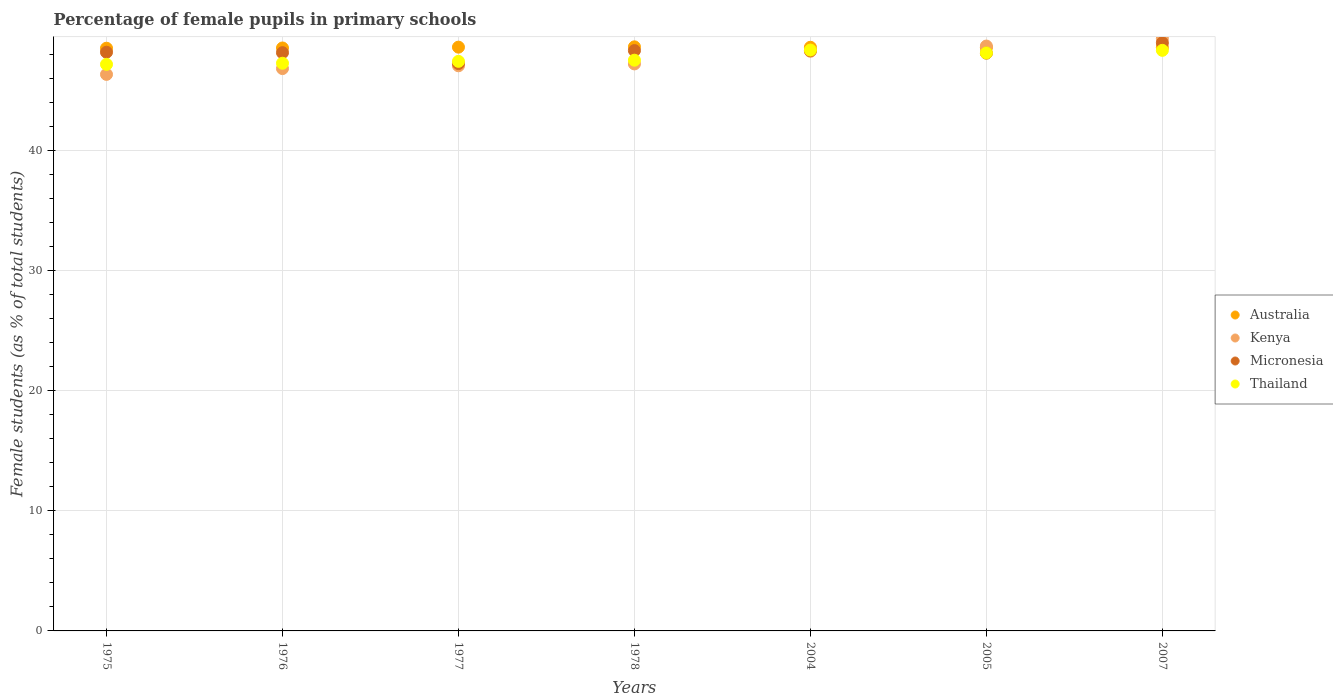How many different coloured dotlines are there?
Keep it short and to the point. 4. What is the percentage of female pupils in primary schools in Thailand in 2007?
Provide a short and direct response. 48.36. Across all years, what is the maximum percentage of female pupils in primary schools in Kenya?
Your answer should be compact. 49.36. Across all years, what is the minimum percentage of female pupils in primary schools in Micronesia?
Your answer should be very brief. 47.26. In which year was the percentage of female pupils in primary schools in Australia minimum?
Provide a short and direct response. 1975. What is the total percentage of female pupils in primary schools in Kenya in the graph?
Provide a short and direct response. 333.86. What is the difference between the percentage of female pupils in primary schools in Thailand in 1976 and that in 1978?
Make the answer very short. -0.25. What is the difference between the percentage of female pupils in primary schools in Kenya in 2004 and the percentage of female pupils in primary schools in Thailand in 1977?
Keep it short and to the point. 0.84. What is the average percentage of female pupils in primary schools in Kenya per year?
Offer a very short reply. 47.69. In the year 2007, what is the difference between the percentage of female pupils in primary schools in Micronesia and percentage of female pupils in primary schools in Kenya?
Make the answer very short. -0.37. In how many years, is the percentage of female pupils in primary schools in Thailand greater than 2 %?
Offer a very short reply. 7. What is the ratio of the percentage of female pupils in primary schools in Kenya in 1977 to that in 1978?
Offer a terse response. 1. Is the percentage of female pupils in primary schools in Thailand in 1976 less than that in 2007?
Provide a succinct answer. Yes. Is the difference between the percentage of female pupils in primary schools in Micronesia in 1975 and 2007 greater than the difference between the percentage of female pupils in primary schools in Kenya in 1975 and 2007?
Make the answer very short. Yes. What is the difference between the highest and the second highest percentage of female pupils in primary schools in Kenya?
Ensure brevity in your answer.  0.64. What is the difference between the highest and the lowest percentage of female pupils in primary schools in Thailand?
Provide a short and direct response. 1.19. In how many years, is the percentage of female pupils in primary schools in Kenya greater than the average percentage of female pupils in primary schools in Kenya taken over all years?
Your response must be concise. 3. Is it the case that in every year, the sum of the percentage of female pupils in primary schools in Kenya and percentage of female pupils in primary schools in Micronesia  is greater than the percentage of female pupils in primary schools in Australia?
Make the answer very short. Yes. Is the percentage of female pupils in primary schools in Kenya strictly less than the percentage of female pupils in primary schools in Australia over the years?
Make the answer very short. No. How many years are there in the graph?
Provide a short and direct response. 7. Are the values on the major ticks of Y-axis written in scientific E-notation?
Your answer should be compact. No. Does the graph contain any zero values?
Offer a terse response. No. Does the graph contain grids?
Your answer should be very brief. Yes. How many legend labels are there?
Give a very brief answer. 4. How are the legend labels stacked?
Your response must be concise. Vertical. What is the title of the graph?
Keep it short and to the point. Percentage of female pupils in primary schools. What is the label or title of the X-axis?
Offer a terse response. Years. What is the label or title of the Y-axis?
Your answer should be very brief. Female students (as % of total students). What is the Female students (as % of total students) of Australia in 1975?
Your response must be concise. 48.54. What is the Female students (as % of total students) of Kenya in 1975?
Ensure brevity in your answer.  46.36. What is the Female students (as % of total students) of Micronesia in 1975?
Offer a very short reply. 48.2. What is the Female students (as % of total students) in Thailand in 1975?
Offer a terse response. 47.2. What is the Female students (as % of total students) of Australia in 1976?
Your answer should be compact. 48.56. What is the Female students (as % of total students) in Kenya in 1976?
Ensure brevity in your answer.  46.84. What is the Female students (as % of total students) in Micronesia in 1976?
Ensure brevity in your answer.  48.17. What is the Female students (as % of total students) in Thailand in 1976?
Your answer should be very brief. 47.29. What is the Female students (as % of total students) of Australia in 1977?
Your answer should be very brief. 48.63. What is the Female students (as % of total students) in Kenya in 1977?
Provide a short and direct response. 47.08. What is the Female students (as % of total students) in Micronesia in 1977?
Your response must be concise. 47.26. What is the Female students (as % of total students) of Thailand in 1977?
Give a very brief answer. 47.45. What is the Female students (as % of total students) in Australia in 1978?
Give a very brief answer. 48.65. What is the Female students (as % of total students) in Kenya in 1978?
Your response must be concise. 47.23. What is the Female students (as % of total students) of Micronesia in 1978?
Offer a very short reply. 48.34. What is the Female students (as % of total students) of Thailand in 1978?
Offer a terse response. 47.54. What is the Female students (as % of total students) in Australia in 2004?
Keep it short and to the point. 48.62. What is the Female students (as % of total students) in Kenya in 2004?
Offer a terse response. 48.28. What is the Female students (as % of total students) in Micronesia in 2004?
Offer a terse response. 48.33. What is the Female students (as % of total students) of Thailand in 2004?
Give a very brief answer. 48.39. What is the Female students (as % of total students) of Australia in 2005?
Give a very brief answer. 48.59. What is the Female students (as % of total students) in Kenya in 2005?
Your response must be concise. 48.72. What is the Female students (as % of total students) in Micronesia in 2005?
Provide a short and direct response. 48.12. What is the Female students (as % of total students) in Thailand in 2005?
Make the answer very short. 48.14. What is the Female students (as % of total students) of Australia in 2007?
Your response must be concise. 48.6. What is the Female students (as % of total students) of Kenya in 2007?
Provide a succinct answer. 49.36. What is the Female students (as % of total students) in Micronesia in 2007?
Provide a succinct answer. 48.98. What is the Female students (as % of total students) in Thailand in 2007?
Keep it short and to the point. 48.36. Across all years, what is the maximum Female students (as % of total students) of Australia?
Provide a succinct answer. 48.65. Across all years, what is the maximum Female students (as % of total students) of Kenya?
Provide a short and direct response. 49.36. Across all years, what is the maximum Female students (as % of total students) of Micronesia?
Your answer should be very brief. 48.98. Across all years, what is the maximum Female students (as % of total students) of Thailand?
Your response must be concise. 48.39. Across all years, what is the minimum Female students (as % of total students) in Australia?
Provide a succinct answer. 48.54. Across all years, what is the minimum Female students (as % of total students) of Kenya?
Provide a succinct answer. 46.36. Across all years, what is the minimum Female students (as % of total students) of Micronesia?
Provide a short and direct response. 47.26. Across all years, what is the minimum Female students (as % of total students) of Thailand?
Provide a succinct answer. 47.2. What is the total Female students (as % of total students) of Australia in the graph?
Your answer should be very brief. 340.18. What is the total Female students (as % of total students) in Kenya in the graph?
Ensure brevity in your answer.  333.86. What is the total Female students (as % of total students) of Micronesia in the graph?
Ensure brevity in your answer.  337.41. What is the total Female students (as % of total students) in Thailand in the graph?
Offer a very short reply. 334.36. What is the difference between the Female students (as % of total students) of Australia in 1975 and that in 1976?
Offer a very short reply. -0.02. What is the difference between the Female students (as % of total students) in Kenya in 1975 and that in 1976?
Your response must be concise. -0.48. What is the difference between the Female students (as % of total students) of Micronesia in 1975 and that in 1976?
Your answer should be compact. 0.04. What is the difference between the Female students (as % of total students) in Thailand in 1975 and that in 1976?
Make the answer very short. -0.09. What is the difference between the Female students (as % of total students) in Australia in 1975 and that in 1977?
Provide a succinct answer. -0.09. What is the difference between the Female students (as % of total students) in Kenya in 1975 and that in 1977?
Provide a succinct answer. -0.72. What is the difference between the Female students (as % of total students) of Micronesia in 1975 and that in 1977?
Make the answer very short. 0.95. What is the difference between the Female students (as % of total students) in Thailand in 1975 and that in 1977?
Offer a very short reply. -0.25. What is the difference between the Female students (as % of total students) in Australia in 1975 and that in 1978?
Provide a succinct answer. -0.11. What is the difference between the Female students (as % of total students) of Kenya in 1975 and that in 1978?
Make the answer very short. -0.87. What is the difference between the Female students (as % of total students) in Micronesia in 1975 and that in 1978?
Provide a succinct answer. -0.14. What is the difference between the Female students (as % of total students) in Thailand in 1975 and that in 1978?
Give a very brief answer. -0.35. What is the difference between the Female students (as % of total students) of Australia in 1975 and that in 2004?
Keep it short and to the point. -0.08. What is the difference between the Female students (as % of total students) in Kenya in 1975 and that in 2004?
Provide a succinct answer. -1.93. What is the difference between the Female students (as % of total students) of Micronesia in 1975 and that in 2004?
Your answer should be very brief. -0.13. What is the difference between the Female students (as % of total students) of Thailand in 1975 and that in 2004?
Make the answer very short. -1.19. What is the difference between the Female students (as % of total students) in Australia in 1975 and that in 2005?
Make the answer very short. -0.05. What is the difference between the Female students (as % of total students) of Kenya in 1975 and that in 2005?
Provide a succinct answer. -2.36. What is the difference between the Female students (as % of total students) in Micronesia in 1975 and that in 2005?
Ensure brevity in your answer.  0.08. What is the difference between the Female students (as % of total students) in Thailand in 1975 and that in 2005?
Your answer should be compact. -0.95. What is the difference between the Female students (as % of total students) of Australia in 1975 and that in 2007?
Offer a terse response. -0.06. What is the difference between the Female students (as % of total students) in Kenya in 1975 and that in 2007?
Your answer should be compact. -3. What is the difference between the Female students (as % of total students) in Micronesia in 1975 and that in 2007?
Offer a very short reply. -0.78. What is the difference between the Female students (as % of total students) in Thailand in 1975 and that in 2007?
Your answer should be very brief. -1.17. What is the difference between the Female students (as % of total students) in Australia in 1976 and that in 1977?
Your response must be concise. -0.07. What is the difference between the Female students (as % of total students) in Kenya in 1976 and that in 1977?
Offer a very short reply. -0.23. What is the difference between the Female students (as % of total students) of Micronesia in 1976 and that in 1977?
Keep it short and to the point. 0.91. What is the difference between the Female students (as % of total students) in Thailand in 1976 and that in 1977?
Provide a short and direct response. -0.16. What is the difference between the Female students (as % of total students) in Australia in 1976 and that in 1978?
Ensure brevity in your answer.  -0.09. What is the difference between the Female students (as % of total students) in Kenya in 1976 and that in 1978?
Your answer should be compact. -0.39. What is the difference between the Female students (as % of total students) in Micronesia in 1976 and that in 1978?
Offer a very short reply. -0.17. What is the difference between the Female students (as % of total students) of Thailand in 1976 and that in 1978?
Your answer should be very brief. -0.25. What is the difference between the Female students (as % of total students) in Australia in 1976 and that in 2004?
Ensure brevity in your answer.  -0.06. What is the difference between the Female students (as % of total students) of Kenya in 1976 and that in 2004?
Ensure brevity in your answer.  -1.44. What is the difference between the Female students (as % of total students) of Micronesia in 1976 and that in 2004?
Your response must be concise. -0.17. What is the difference between the Female students (as % of total students) in Thailand in 1976 and that in 2004?
Provide a succinct answer. -1.1. What is the difference between the Female students (as % of total students) in Australia in 1976 and that in 2005?
Keep it short and to the point. -0.03. What is the difference between the Female students (as % of total students) in Kenya in 1976 and that in 2005?
Offer a terse response. -1.88. What is the difference between the Female students (as % of total students) of Micronesia in 1976 and that in 2005?
Provide a succinct answer. 0.04. What is the difference between the Female students (as % of total students) of Thailand in 1976 and that in 2005?
Offer a terse response. -0.86. What is the difference between the Female students (as % of total students) in Australia in 1976 and that in 2007?
Your response must be concise. -0.04. What is the difference between the Female students (as % of total students) in Kenya in 1976 and that in 2007?
Offer a terse response. -2.52. What is the difference between the Female students (as % of total students) in Micronesia in 1976 and that in 2007?
Keep it short and to the point. -0.82. What is the difference between the Female students (as % of total students) of Thailand in 1976 and that in 2007?
Your answer should be very brief. -1.07. What is the difference between the Female students (as % of total students) in Australia in 1977 and that in 1978?
Your response must be concise. -0.03. What is the difference between the Female students (as % of total students) of Kenya in 1977 and that in 1978?
Your answer should be compact. -0.15. What is the difference between the Female students (as % of total students) in Micronesia in 1977 and that in 1978?
Provide a short and direct response. -1.08. What is the difference between the Female students (as % of total students) in Thailand in 1977 and that in 1978?
Make the answer very short. -0.1. What is the difference between the Female students (as % of total students) in Australia in 1977 and that in 2004?
Offer a very short reply. 0.01. What is the difference between the Female students (as % of total students) in Kenya in 1977 and that in 2004?
Your answer should be very brief. -1.21. What is the difference between the Female students (as % of total students) in Micronesia in 1977 and that in 2004?
Your answer should be compact. -1.08. What is the difference between the Female students (as % of total students) of Thailand in 1977 and that in 2004?
Provide a short and direct response. -0.94. What is the difference between the Female students (as % of total students) in Australia in 1977 and that in 2005?
Offer a terse response. 0.04. What is the difference between the Female students (as % of total students) of Kenya in 1977 and that in 2005?
Your answer should be compact. -1.64. What is the difference between the Female students (as % of total students) in Micronesia in 1977 and that in 2005?
Keep it short and to the point. -0.87. What is the difference between the Female students (as % of total students) of Thailand in 1977 and that in 2005?
Your response must be concise. -0.7. What is the difference between the Female students (as % of total students) in Australia in 1977 and that in 2007?
Offer a very short reply. 0.03. What is the difference between the Female students (as % of total students) in Kenya in 1977 and that in 2007?
Keep it short and to the point. -2.28. What is the difference between the Female students (as % of total students) in Micronesia in 1977 and that in 2007?
Offer a very short reply. -1.73. What is the difference between the Female students (as % of total students) in Thailand in 1977 and that in 2007?
Your response must be concise. -0.92. What is the difference between the Female students (as % of total students) of Australia in 1978 and that in 2004?
Offer a terse response. 0.04. What is the difference between the Female students (as % of total students) in Kenya in 1978 and that in 2004?
Give a very brief answer. -1.05. What is the difference between the Female students (as % of total students) in Micronesia in 1978 and that in 2004?
Give a very brief answer. 0.01. What is the difference between the Female students (as % of total students) in Thailand in 1978 and that in 2004?
Give a very brief answer. -0.84. What is the difference between the Female students (as % of total students) of Australia in 1978 and that in 2005?
Make the answer very short. 0.06. What is the difference between the Female students (as % of total students) of Kenya in 1978 and that in 2005?
Provide a succinct answer. -1.49. What is the difference between the Female students (as % of total students) of Micronesia in 1978 and that in 2005?
Keep it short and to the point. 0.22. What is the difference between the Female students (as % of total students) in Thailand in 1978 and that in 2005?
Provide a succinct answer. -0.6. What is the difference between the Female students (as % of total students) in Australia in 1978 and that in 2007?
Provide a succinct answer. 0.05. What is the difference between the Female students (as % of total students) in Kenya in 1978 and that in 2007?
Offer a terse response. -2.13. What is the difference between the Female students (as % of total students) in Micronesia in 1978 and that in 2007?
Provide a succinct answer. -0.64. What is the difference between the Female students (as % of total students) in Thailand in 1978 and that in 2007?
Your answer should be compact. -0.82. What is the difference between the Female students (as % of total students) of Australia in 2004 and that in 2005?
Give a very brief answer. 0.02. What is the difference between the Female students (as % of total students) of Kenya in 2004 and that in 2005?
Provide a short and direct response. -0.43. What is the difference between the Female students (as % of total students) in Micronesia in 2004 and that in 2005?
Ensure brevity in your answer.  0.21. What is the difference between the Female students (as % of total students) in Thailand in 2004 and that in 2005?
Your answer should be very brief. 0.24. What is the difference between the Female students (as % of total students) in Australia in 2004 and that in 2007?
Provide a succinct answer. 0.02. What is the difference between the Female students (as % of total students) of Kenya in 2004 and that in 2007?
Ensure brevity in your answer.  -1.07. What is the difference between the Female students (as % of total students) of Micronesia in 2004 and that in 2007?
Provide a succinct answer. -0.65. What is the difference between the Female students (as % of total students) in Thailand in 2004 and that in 2007?
Your answer should be very brief. 0.03. What is the difference between the Female students (as % of total students) in Australia in 2005 and that in 2007?
Offer a very short reply. -0.01. What is the difference between the Female students (as % of total students) of Kenya in 2005 and that in 2007?
Ensure brevity in your answer.  -0.64. What is the difference between the Female students (as % of total students) of Micronesia in 2005 and that in 2007?
Give a very brief answer. -0.86. What is the difference between the Female students (as % of total students) in Thailand in 2005 and that in 2007?
Offer a very short reply. -0.22. What is the difference between the Female students (as % of total students) of Australia in 1975 and the Female students (as % of total students) of Kenya in 1976?
Give a very brief answer. 1.7. What is the difference between the Female students (as % of total students) of Australia in 1975 and the Female students (as % of total students) of Micronesia in 1976?
Make the answer very short. 0.37. What is the difference between the Female students (as % of total students) in Australia in 1975 and the Female students (as % of total students) in Thailand in 1976?
Offer a very short reply. 1.25. What is the difference between the Female students (as % of total students) of Kenya in 1975 and the Female students (as % of total students) of Micronesia in 1976?
Offer a very short reply. -1.81. What is the difference between the Female students (as % of total students) in Kenya in 1975 and the Female students (as % of total students) in Thailand in 1976?
Your answer should be very brief. -0.93. What is the difference between the Female students (as % of total students) of Micronesia in 1975 and the Female students (as % of total students) of Thailand in 1976?
Provide a succinct answer. 0.92. What is the difference between the Female students (as % of total students) in Australia in 1975 and the Female students (as % of total students) in Kenya in 1977?
Offer a very short reply. 1.46. What is the difference between the Female students (as % of total students) of Australia in 1975 and the Female students (as % of total students) of Micronesia in 1977?
Offer a terse response. 1.28. What is the difference between the Female students (as % of total students) of Australia in 1975 and the Female students (as % of total students) of Thailand in 1977?
Provide a short and direct response. 1.09. What is the difference between the Female students (as % of total students) in Kenya in 1975 and the Female students (as % of total students) in Micronesia in 1977?
Offer a terse response. -0.9. What is the difference between the Female students (as % of total students) in Kenya in 1975 and the Female students (as % of total students) in Thailand in 1977?
Offer a very short reply. -1.09. What is the difference between the Female students (as % of total students) in Micronesia in 1975 and the Female students (as % of total students) in Thailand in 1977?
Offer a very short reply. 0.76. What is the difference between the Female students (as % of total students) of Australia in 1975 and the Female students (as % of total students) of Kenya in 1978?
Your answer should be compact. 1.31. What is the difference between the Female students (as % of total students) in Australia in 1975 and the Female students (as % of total students) in Micronesia in 1978?
Provide a short and direct response. 0.2. What is the difference between the Female students (as % of total students) in Australia in 1975 and the Female students (as % of total students) in Thailand in 1978?
Offer a very short reply. 1. What is the difference between the Female students (as % of total students) of Kenya in 1975 and the Female students (as % of total students) of Micronesia in 1978?
Offer a terse response. -1.98. What is the difference between the Female students (as % of total students) of Kenya in 1975 and the Female students (as % of total students) of Thailand in 1978?
Provide a succinct answer. -1.18. What is the difference between the Female students (as % of total students) of Micronesia in 1975 and the Female students (as % of total students) of Thailand in 1978?
Give a very brief answer. 0.66. What is the difference between the Female students (as % of total students) in Australia in 1975 and the Female students (as % of total students) in Kenya in 2004?
Offer a very short reply. 0.25. What is the difference between the Female students (as % of total students) of Australia in 1975 and the Female students (as % of total students) of Micronesia in 2004?
Ensure brevity in your answer.  0.2. What is the difference between the Female students (as % of total students) of Australia in 1975 and the Female students (as % of total students) of Thailand in 2004?
Your answer should be very brief. 0.15. What is the difference between the Female students (as % of total students) in Kenya in 1975 and the Female students (as % of total students) in Micronesia in 2004?
Your answer should be very brief. -1.97. What is the difference between the Female students (as % of total students) in Kenya in 1975 and the Female students (as % of total students) in Thailand in 2004?
Offer a very short reply. -2.03. What is the difference between the Female students (as % of total students) in Micronesia in 1975 and the Female students (as % of total students) in Thailand in 2004?
Give a very brief answer. -0.18. What is the difference between the Female students (as % of total students) in Australia in 1975 and the Female students (as % of total students) in Kenya in 2005?
Your response must be concise. -0.18. What is the difference between the Female students (as % of total students) in Australia in 1975 and the Female students (as % of total students) in Micronesia in 2005?
Make the answer very short. 0.41. What is the difference between the Female students (as % of total students) in Australia in 1975 and the Female students (as % of total students) in Thailand in 2005?
Offer a terse response. 0.39. What is the difference between the Female students (as % of total students) in Kenya in 1975 and the Female students (as % of total students) in Micronesia in 2005?
Provide a succinct answer. -1.77. What is the difference between the Female students (as % of total students) of Kenya in 1975 and the Female students (as % of total students) of Thailand in 2005?
Give a very brief answer. -1.79. What is the difference between the Female students (as % of total students) in Micronesia in 1975 and the Female students (as % of total students) in Thailand in 2005?
Your answer should be compact. 0.06. What is the difference between the Female students (as % of total students) of Australia in 1975 and the Female students (as % of total students) of Kenya in 2007?
Ensure brevity in your answer.  -0.82. What is the difference between the Female students (as % of total students) in Australia in 1975 and the Female students (as % of total students) in Micronesia in 2007?
Keep it short and to the point. -0.45. What is the difference between the Female students (as % of total students) in Australia in 1975 and the Female students (as % of total students) in Thailand in 2007?
Provide a short and direct response. 0.18. What is the difference between the Female students (as % of total students) of Kenya in 1975 and the Female students (as % of total students) of Micronesia in 2007?
Make the answer very short. -2.63. What is the difference between the Female students (as % of total students) of Kenya in 1975 and the Female students (as % of total students) of Thailand in 2007?
Provide a succinct answer. -2. What is the difference between the Female students (as % of total students) in Micronesia in 1975 and the Female students (as % of total students) in Thailand in 2007?
Your response must be concise. -0.16. What is the difference between the Female students (as % of total students) of Australia in 1976 and the Female students (as % of total students) of Kenya in 1977?
Your answer should be compact. 1.48. What is the difference between the Female students (as % of total students) in Australia in 1976 and the Female students (as % of total students) in Micronesia in 1977?
Ensure brevity in your answer.  1.3. What is the difference between the Female students (as % of total students) in Australia in 1976 and the Female students (as % of total students) in Thailand in 1977?
Offer a very short reply. 1.11. What is the difference between the Female students (as % of total students) in Kenya in 1976 and the Female students (as % of total students) in Micronesia in 1977?
Provide a short and direct response. -0.42. What is the difference between the Female students (as % of total students) of Kenya in 1976 and the Female students (as % of total students) of Thailand in 1977?
Ensure brevity in your answer.  -0.6. What is the difference between the Female students (as % of total students) in Micronesia in 1976 and the Female students (as % of total students) in Thailand in 1977?
Provide a short and direct response. 0.72. What is the difference between the Female students (as % of total students) of Australia in 1976 and the Female students (as % of total students) of Kenya in 1978?
Ensure brevity in your answer.  1.33. What is the difference between the Female students (as % of total students) of Australia in 1976 and the Female students (as % of total students) of Micronesia in 1978?
Your answer should be compact. 0.22. What is the difference between the Female students (as % of total students) in Australia in 1976 and the Female students (as % of total students) in Thailand in 1978?
Your response must be concise. 1.02. What is the difference between the Female students (as % of total students) of Kenya in 1976 and the Female students (as % of total students) of Micronesia in 1978?
Offer a very short reply. -1.5. What is the difference between the Female students (as % of total students) of Kenya in 1976 and the Female students (as % of total students) of Thailand in 1978?
Offer a very short reply. -0.7. What is the difference between the Female students (as % of total students) in Micronesia in 1976 and the Female students (as % of total students) in Thailand in 1978?
Make the answer very short. 0.63. What is the difference between the Female students (as % of total students) of Australia in 1976 and the Female students (as % of total students) of Kenya in 2004?
Provide a short and direct response. 0.27. What is the difference between the Female students (as % of total students) of Australia in 1976 and the Female students (as % of total students) of Micronesia in 2004?
Provide a succinct answer. 0.23. What is the difference between the Female students (as % of total students) in Australia in 1976 and the Female students (as % of total students) in Thailand in 2004?
Make the answer very short. 0.17. What is the difference between the Female students (as % of total students) in Kenya in 1976 and the Female students (as % of total students) in Micronesia in 2004?
Ensure brevity in your answer.  -1.49. What is the difference between the Female students (as % of total students) in Kenya in 1976 and the Female students (as % of total students) in Thailand in 2004?
Offer a terse response. -1.54. What is the difference between the Female students (as % of total students) in Micronesia in 1976 and the Female students (as % of total students) in Thailand in 2004?
Your answer should be very brief. -0.22. What is the difference between the Female students (as % of total students) in Australia in 1976 and the Female students (as % of total students) in Kenya in 2005?
Ensure brevity in your answer.  -0.16. What is the difference between the Female students (as % of total students) of Australia in 1976 and the Female students (as % of total students) of Micronesia in 2005?
Ensure brevity in your answer.  0.43. What is the difference between the Female students (as % of total students) in Australia in 1976 and the Female students (as % of total students) in Thailand in 2005?
Offer a terse response. 0.41. What is the difference between the Female students (as % of total students) in Kenya in 1976 and the Female students (as % of total students) in Micronesia in 2005?
Your response must be concise. -1.28. What is the difference between the Female students (as % of total students) in Kenya in 1976 and the Female students (as % of total students) in Thailand in 2005?
Give a very brief answer. -1.3. What is the difference between the Female students (as % of total students) of Micronesia in 1976 and the Female students (as % of total students) of Thailand in 2005?
Provide a short and direct response. 0.02. What is the difference between the Female students (as % of total students) in Australia in 1976 and the Female students (as % of total students) in Kenya in 2007?
Provide a short and direct response. -0.8. What is the difference between the Female students (as % of total students) in Australia in 1976 and the Female students (as % of total students) in Micronesia in 2007?
Provide a succinct answer. -0.43. What is the difference between the Female students (as % of total students) in Australia in 1976 and the Female students (as % of total students) in Thailand in 2007?
Ensure brevity in your answer.  0.2. What is the difference between the Female students (as % of total students) in Kenya in 1976 and the Female students (as % of total students) in Micronesia in 2007?
Your response must be concise. -2.14. What is the difference between the Female students (as % of total students) in Kenya in 1976 and the Female students (as % of total students) in Thailand in 2007?
Provide a succinct answer. -1.52. What is the difference between the Female students (as % of total students) in Micronesia in 1976 and the Female students (as % of total students) in Thailand in 2007?
Your response must be concise. -0.19. What is the difference between the Female students (as % of total students) of Australia in 1977 and the Female students (as % of total students) of Kenya in 1978?
Your answer should be compact. 1.4. What is the difference between the Female students (as % of total students) of Australia in 1977 and the Female students (as % of total students) of Micronesia in 1978?
Your answer should be compact. 0.29. What is the difference between the Female students (as % of total students) of Australia in 1977 and the Female students (as % of total students) of Thailand in 1978?
Give a very brief answer. 1.09. What is the difference between the Female students (as % of total students) in Kenya in 1977 and the Female students (as % of total students) in Micronesia in 1978?
Make the answer very short. -1.27. What is the difference between the Female students (as % of total students) in Kenya in 1977 and the Female students (as % of total students) in Thailand in 1978?
Make the answer very short. -0.47. What is the difference between the Female students (as % of total students) in Micronesia in 1977 and the Female students (as % of total students) in Thailand in 1978?
Ensure brevity in your answer.  -0.28. What is the difference between the Female students (as % of total students) of Australia in 1977 and the Female students (as % of total students) of Kenya in 2004?
Your answer should be very brief. 0.34. What is the difference between the Female students (as % of total students) in Australia in 1977 and the Female students (as % of total students) in Micronesia in 2004?
Your answer should be compact. 0.29. What is the difference between the Female students (as % of total students) in Australia in 1977 and the Female students (as % of total students) in Thailand in 2004?
Offer a very short reply. 0.24. What is the difference between the Female students (as % of total students) in Kenya in 1977 and the Female students (as % of total students) in Micronesia in 2004?
Provide a succinct answer. -1.26. What is the difference between the Female students (as % of total students) in Kenya in 1977 and the Female students (as % of total students) in Thailand in 2004?
Provide a short and direct response. -1.31. What is the difference between the Female students (as % of total students) of Micronesia in 1977 and the Female students (as % of total students) of Thailand in 2004?
Your answer should be very brief. -1.13. What is the difference between the Female students (as % of total students) in Australia in 1977 and the Female students (as % of total students) in Kenya in 2005?
Your response must be concise. -0.09. What is the difference between the Female students (as % of total students) in Australia in 1977 and the Female students (as % of total students) in Micronesia in 2005?
Offer a very short reply. 0.5. What is the difference between the Female students (as % of total students) in Australia in 1977 and the Female students (as % of total students) in Thailand in 2005?
Give a very brief answer. 0.48. What is the difference between the Female students (as % of total students) in Kenya in 1977 and the Female students (as % of total students) in Micronesia in 2005?
Make the answer very short. -1.05. What is the difference between the Female students (as % of total students) of Kenya in 1977 and the Female students (as % of total students) of Thailand in 2005?
Offer a very short reply. -1.07. What is the difference between the Female students (as % of total students) of Micronesia in 1977 and the Female students (as % of total students) of Thailand in 2005?
Make the answer very short. -0.89. What is the difference between the Female students (as % of total students) of Australia in 1977 and the Female students (as % of total students) of Kenya in 2007?
Your answer should be very brief. -0.73. What is the difference between the Female students (as % of total students) of Australia in 1977 and the Female students (as % of total students) of Micronesia in 2007?
Offer a very short reply. -0.36. What is the difference between the Female students (as % of total students) in Australia in 1977 and the Female students (as % of total students) in Thailand in 2007?
Keep it short and to the point. 0.27. What is the difference between the Female students (as % of total students) in Kenya in 1977 and the Female students (as % of total students) in Micronesia in 2007?
Your answer should be compact. -1.91. What is the difference between the Female students (as % of total students) of Kenya in 1977 and the Female students (as % of total students) of Thailand in 2007?
Provide a short and direct response. -1.29. What is the difference between the Female students (as % of total students) in Micronesia in 1977 and the Female students (as % of total students) in Thailand in 2007?
Provide a succinct answer. -1.1. What is the difference between the Female students (as % of total students) in Australia in 1978 and the Female students (as % of total students) in Kenya in 2004?
Make the answer very short. 0.37. What is the difference between the Female students (as % of total students) in Australia in 1978 and the Female students (as % of total students) in Micronesia in 2004?
Provide a short and direct response. 0.32. What is the difference between the Female students (as % of total students) in Australia in 1978 and the Female students (as % of total students) in Thailand in 2004?
Your response must be concise. 0.27. What is the difference between the Female students (as % of total students) of Kenya in 1978 and the Female students (as % of total students) of Micronesia in 2004?
Offer a very short reply. -1.1. What is the difference between the Female students (as % of total students) in Kenya in 1978 and the Female students (as % of total students) in Thailand in 2004?
Make the answer very short. -1.16. What is the difference between the Female students (as % of total students) of Micronesia in 1978 and the Female students (as % of total students) of Thailand in 2004?
Provide a short and direct response. -0.04. What is the difference between the Female students (as % of total students) in Australia in 1978 and the Female students (as % of total students) in Kenya in 2005?
Keep it short and to the point. -0.07. What is the difference between the Female students (as % of total students) in Australia in 1978 and the Female students (as % of total students) in Micronesia in 2005?
Offer a very short reply. 0.53. What is the difference between the Female students (as % of total students) in Australia in 1978 and the Female students (as % of total students) in Thailand in 2005?
Give a very brief answer. 0.51. What is the difference between the Female students (as % of total students) of Kenya in 1978 and the Female students (as % of total students) of Micronesia in 2005?
Your response must be concise. -0.89. What is the difference between the Female students (as % of total students) of Kenya in 1978 and the Female students (as % of total students) of Thailand in 2005?
Provide a short and direct response. -0.91. What is the difference between the Female students (as % of total students) of Micronesia in 1978 and the Female students (as % of total students) of Thailand in 2005?
Keep it short and to the point. 0.2. What is the difference between the Female students (as % of total students) in Australia in 1978 and the Female students (as % of total students) in Kenya in 2007?
Offer a very short reply. -0.71. What is the difference between the Female students (as % of total students) of Australia in 1978 and the Female students (as % of total students) of Micronesia in 2007?
Your answer should be very brief. -0.33. What is the difference between the Female students (as % of total students) in Australia in 1978 and the Female students (as % of total students) in Thailand in 2007?
Keep it short and to the point. 0.29. What is the difference between the Female students (as % of total students) in Kenya in 1978 and the Female students (as % of total students) in Micronesia in 2007?
Your answer should be very brief. -1.75. What is the difference between the Female students (as % of total students) of Kenya in 1978 and the Female students (as % of total students) of Thailand in 2007?
Ensure brevity in your answer.  -1.13. What is the difference between the Female students (as % of total students) of Micronesia in 1978 and the Female students (as % of total students) of Thailand in 2007?
Offer a very short reply. -0.02. What is the difference between the Female students (as % of total students) in Australia in 2004 and the Female students (as % of total students) in Kenya in 2005?
Your answer should be compact. -0.1. What is the difference between the Female students (as % of total students) of Australia in 2004 and the Female students (as % of total students) of Micronesia in 2005?
Keep it short and to the point. 0.49. What is the difference between the Female students (as % of total students) in Australia in 2004 and the Female students (as % of total students) in Thailand in 2005?
Offer a terse response. 0.47. What is the difference between the Female students (as % of total students) in Kenya in 2004 and the Female students (as % of total students) in Micronesia in 2005?
Your answer should be very brief. 0.16. What is the difference between the Female students (as % of total students) of Kenya in 2004 and the Female students (as % of total students) of Thailand in 2005?
Offer a terse response. 0.14. What is the difference between the Female students (as % of total students) of Micronesia in 2004 and the Female students (as % of total students) of Thailand in 2005?
Your answer should be very brief. 0.19. What is the difference between the Female students (as % of total students) in Australia in 2004 and the Female students (as % of total students) in Kenya in 2007?
Offer a terse response. -0.74. What is the difference between the Female students (as % of total students) of Australia in 2004 and the Female students (as % of total students) of Micronesia in 2007?
Your response must be concise. -0.37. What is the difference between the Female students (as % of total students) of Australia in 2004 and the Female students (as % of total students) of Thailand in 2007?
Provide a short and direct response. 0.26. What is the difference between the Female students (as % of total students) of Kenya in 2004 and the Female students (as % of total students) of Micronesia in 2007?
Ensure brevity in your answer.  -0.7. What is the difference between the Female students (as % of total students) in Kenya in 2004 and the Female students (as % of total students) in Thailand in 2007?
Make the answer very short. -0.08. What is the difference between the Female students (as % of total students) in Micronesia in 2004 and the Female students (as % of total students) in Thailand in 2007?
Offer a very short reply. -0.03. What is the difference between the Female students (as % of total students) of Australia in 2005 and the Female students (as % of total students) of Kenya in 2007?
Keep it short and to the point. -0.77. What is the difference between the Female students (as % of total students) of Australia in 2005 and the Female students (as % of total students) of Micronesia in 2007?
Provide a short and direct response. -0.39. What is the difference between the Female students (as % of total students) in Australia in 2005 and the Female students (as % of total students) in Thailand in 2007?
Keep it short and to the point. 0.23. What is the difference between the Female students (as % of total students) in Kenya in 2005 and the Female students (as % of total students) in Micronesia in 2007?
Your answer should be very brief. -0.27. What is the difference between the Female students (as % of total students) of Kenya in 2005 and the Female students (as % of total students) of Thailand in 2007?
Provide a short and direct response. 0.36. What is the difference between the Female students (as % of total students) in Micronesia in 2005 and the Female students (as % of total students) in Thailand in 2007?
Provide a short and direct response. -0.24. What is the average Female students (as % of total students) in Australia per year?
Ensure brevity in your answer.  48.6. What is the average Female students (as % of total students) in Kenya per year?
Offer a very short reply. 47.69. What is the average Female students (as % of total students) in Micronesia per year?
Your response must be concise. 48.2. What is the average Female students (as % of total students) of Thailand per year?
Offer a very short reply. 47.77. In the year 1975, what is the difference between the Female students (as % of total students) in Australia and Female students (as % of total students) in Kenya?
Offer a terse response. 2.18. In the year 1975, what is the difference between the Female students (as % of total students) of Australia and Female students (as % of total students) of Micronesia?
Your answer should be very brief. 0.33. In the year 1975, what is the difference between the Female students (as % of total students) in Australia and Female students (as % of total students) in Thailand?
Offer a very short reply. 1.34. In the year 1975, what is the difference between the Female students (as % of total students) of Kenya and Female students (as % of total students) of Micronesia?
Your response must be concise. -1.85. In the year 1975, what is the difference between the Female students (as % of total students) of Kenya and Female students (as % of total students) of Thailand?
Provide a short and direct response. -0.84. In the year 1975, what is the difference between the Female students (as % of total students) of Micronesia and Female students (as % of total students) of Thailand?
Offer a very short reply. 1.01. In the year 1976, what is the difference between the Female students (as % of total students) in Australia and Female students (as % of total students) in Kenya?
Provide a short and direct response. 1.72. In the year 1976, what is the difference between the Female students (as % of total students) of Australia and Female students (as % of total students) of Micronesia?
Your answer should be compact. 0.39. In the year 1976, what is the difference between the Female students (as % of total students) of Australia and Female students (as % of total students) of Thailand?
Ensure brevity in your answer.  1.27. In the year 1976, what is the difference between the Female students (as % of total students) of Kenya and Female students (as % of total students) of Micronesia?
Your answer should be very brief. -1.33. In the year 1976, what is the difference between the Female students (as % of total students) in Kenya and Female students (as % of total students) in Thailand?
Give a very brief answer. -0.45. In the year 1976, what is the difference between the Female students (as % of total students) of Micronesia and Female students (as % of total students) of Thailand?
Keep it short and to the point. 0.88. In the year 1977, what is the difference between the Female students (as % of total students) of Australia and Female students (as % of total students) of Kenya?
Make the answer very short. 1.55. In the year 1977, what is the difference between the Female students (as % of total students) in Australia and Female students (as % of total students) in Micronesia?
Offer a terse response. 1.37. In the year 1977, what is the difference between the Female students (as % of total students) in Australia and Female students (as % of total students) in Thailand?
Provide a succinct answer. 1.18. In the year 1977, what is the difference between the Female students (as % of total students) of Kenya and Female students (as % of total students) of Micronesia?
Keep it short and to the point. -0.18. In the year 1977, what is the difference between the Female students (as % of total students) of Kenya and Female students (as % of total students) of Thailand?
Your answer should be compact. -0.37. In the year 1977, what is the difference between the Female students (as % of total students) of Micronesia and Female students (as % of total students) of Thailand?
Your answer should be very brief. -0.19. In the year 1978, what is the difference between the Female students (as % of total students) of Australia and Female students (as % of total students) of Kenya?
Offer a very short reply. 1.42. In the year 1978, what is the difference between the Female students (as % of total students) of Australia and Female students (as % of total students) of Micronesia?
Make the answer very short. 0.31. In the year 1978, what is the difference between the Female students (as % of total students) of Australia and Female students (as % of total students) of Thailand?
Your answer should be very brief. 1.11. In the year 1978, what is the difference between the Female students (as % of total students) of Kenya and Female students (as % of total students) of Micronesia?
Provide a short and direct response. -1.11. In the year 1978, what is the difference between the Female students (as % of total students) in Kenya and Female students (as % of total students) in Thailand?
Your answer should be very brief. -0.31. In the year 1978, what is the difference between the Female students (as % of total students) in Micronesia and Female students (as % of total students) in Thailand?
Offer a terse response. 0.8. In the year 2004, what is the difference between the Female students (as % of total students) in Australia and Female students (as % of total students) in Kenya?
Provide a short and direct response. 0.33. In the year 2004, what is the difference between the Female students (as % of total students) in Australia and Female students (as % of total students) in Micronesia?
Ensure brevity in your answer.  0.28. In the year 2004, what is the difference between the Female students (as % of total students) in Australia and Female students (as % of total students) in Thailand?
Keep it short and to the point. 0.23. In the year 2004, what is the difference between the Female students (as % of total students) in Kenya and Female students (as % of total students) in Micronesia?
Keep it short and to the point. -0.05. In the year 2004, what is the difference between the Female students (as % of total students) in Kenya and Female students (as % of total students) in Thailand?
Your response must be concise. -0.1. In the year 2004, what is the difference between the Female students (as % of total students) in Micronesia and Female students (as % of total students) in Thailand?
Make the answer very short. -0.05. In the year 2005, what is the difference between the Female students (as % of total students) of Australia and Female students (as % of total students) of Kenya?
Provide a short and direct response. -0.13. In the year 2005, what is the difference between the Female students (as % of total students) of Australia and Female students (as % of total students) of Micronesia?
Keep it short and to the point. 0.47. In the year 2005, what is the difference between the Female students (as % of total students) of Australia and Female students (as % of total students) of Thailand?
Provide a succinct answer. 0.45. In the year 2005, what is the difference between the Female students (as % of total students) of Kenya and Female students (as % of total students) of Micronesia?
Give a very brief answer. 0.59. In the year 2005, what is the difference between the Female students (as % of total students) in Kenya and Female students (as % of total students) in Thailand?
Offer a terse response. 0.57. In the year 2005, what is the difference between the Female students (as % of total students) of Micronesia and Female students (as % of total students) of Thailand?
Make the answer very short. -0.02. In the year 2007, what is the difference between the Female students (as % of total students) in Australia and Female students (as % of total students) in Kenya?
Make the answer very short. -0.76. In the year 2007, what is the difference between the Female students (as % of total students) in Australia and Female students (as % of total students) in Micronesia?
Your response must be concise. -0.39. In the year 2007, what is the difference between the Female students (as % of total students) of Australia and Female students (as % of total students) of Thailand?
Offer a terse response. 0.24. In the year 2007, what is the difference between the Female students (as % of total students) of Kenya and Female students (as % of total students) of Micronesia?
Your answer should be very brief. 0.37. In the year 2007, what is the difference between the Female students (as % of total students) in Micronesia and Female students (as % of total students) in Thailand?
Offer a very short reply. 0.62. What is the ratio of the Female students (as % of total students) in Australia in 1975 to that in 1976?
Make the answer very short. 1. What is the ratio of the Female students (as % of total students) in Micronesia in 1975 to that in 1976?
Your answer should be compact. 1. What is the ratio of the Female students (as % of total students) in Thailand in 1975 to that in 1976?
Your response must be concise. 1. What is the ratio of the Female students (as % of total students) of Kenya in 1975 to that in 1977?
Your response must be concise. 0.98. What is the ratio of the Female students (as % of total students) of Thailand in 1975 to that in 1977?
Give a very brief answer. 0.99. What is the ratio of the Female students (as % of total students) of Australia in 1975 to that in 1978?
Keep it short and to the point. 1. What is the ratio of the Female students (as % of total students) of Kenya in 1975 to that in 1978?
Provide a succinct answer. 0.98. What is the ratio of the Female students (as % of total students) of Micronesia in 1975 to that in 1978?
Make the answer very short. 1. What is the ratio of the Female students (as % of total students) of Australia in 1975 to that in 2004?
Ensure brevity in your answer.  1. What is the ratio of the Female students (as % of total students) in Kenya in 1975 to that in 2004?
Your answer should be compact. 0.96. What is the ratio of the Female students (as % of total students) of Thailand in 1975 to that in 2004?
Provide a short and direct response. 0.98. What is the ratio of the Female students (as % of total students) of Kenya in 1975 to that in 2005?
Your answer should be very brief. 0.95. What is the ratio of the Female students (as % of total students) in Micronesia in 1975 to that in 2005?
Ensure brevity in your answer.  1. What is the ratio of the Female students (as % of total students) in Thailand in 1975 to that in 2005?
Ensure brevity in your answer.  0.98. What is the ratio of the Female students (as % of total students) in Kenya in 1975 to that in 2007?
Ensure brevity in your answer.  0.94. What is the ratio of the Female students (as % of total students) in Micronesia in 1975 to that in 2007?
Your answer should be compact. 0.98. What is the ratio of the Female students (as % of total students) of Thailand in 1975 to that in 2007?
Offer a terse response. 0.98. What is the ratio of the Female students (as % of total students) of Australia in 1976 to that in 1977?
Make the answer very short. 1. What is the ratio of the Female students (as % of total students) of Micronesia in 1976 to that in 1977?
Keep it short and to the point. 1.02. What is the ratio of the Female students (as % of total students) in Thailand in 1976 to that in 1977?
Keep it short and to the point. 1. What is the ratio of the Female students (as % of total students) in Micronesia in 1976 to that in 1978?
Make the answer very short. 1. What is the ratio of the Female students (as % of total students) in Australia in 1976 to that in 2004?
Keep it short and to the point. 1. What is the ratio of the Female students (as % of total students) of Kenya in 1976 to that in 2004?
Provide a short and direct response. 0.97. What is the ratio of the Female students (as % of total students) of Thailand in 1976 to that in 2004?
Provide a short and direct response. 0.98. What is the ratio of the Female students (as % of total students) in Kenya in 1976 to that in 2005?
Your answer should be compact. 0.96. What is the ratio of the Female students (as % of total students) in Micronesia in 1976 to that in 2005?
Your answer should be compact. 1. What is the ratio of the Female students (as % of total students) in Thailand in 1976 to that in 2005?
Your answer should be very brief. 0.98. What is the ratio of the Female students (as % of total students) of Australia in 1976 to that in 2007?
Provide a short and direct response. 1. What is the ratio of the Female students (as % of total students) in Kenya in 1976 to that in 2007?
Make the answer very short. 0.95. What is the ratio of the Female students (as % of total students) of Micronesia in 1976 to that in 2007?
Your response must be concise. 0.98. What is the ratio of the Female students (as % of total students) in Thailand in 1976 to that in 2007?
Ensure brevity in your answer.  0.98. What is the ratio of the Female students (as % of total students) of Australia in 1977 to that in 1978?
Ensure brevity in your answer.  1. What is the ratio of the Female students (as % of total students) of Micronesia in 1977 to that in 1978?
Offer a very short reply. 0.98. What is the ratio of the Female students (as % of total students) in Thailand in 1977 to that in 1978?
Provide a succinct answer. 1. What is the ratio of the Female students (as % of total students) of Australia in 1977 to that in 2004?
Ensure brevity in your answer.  1. What is the ratio of the Female students (as % of total students) in Kenya in 1977 to that in 2004?
Give a very brief answer. 0.97. What is the ratio of the Female students (as % of total students) of Micronesia in 1977 to that in 2004?
Provide a short and direct response. 0.98. What is the ratio of the Female students (as % of total students) of Thailand in 1977 to that in 2004?
Your answer should be very brief. 0.98. What is the ratio of the Female students (as % of total students) in Kenya in 1977 to that in 2005?
Keep it short and to the point. 0.97. What is the ratio of the Female students (as % of total students) in Thailand in 1977 to that in 2005?
Offer a very short reply. 0.99. What is the ratio of the Female students (as % of total students) of Australia in 1977 to that in 2007?
Your response must be concise. 1. What is the ratio of the Female students (as % of total students) in Kenya in 1977 to that in 2007?
Ensure brevity in your answer.  0.95. What is the ratio of the Female students (as % of total students) in Micronesia in 1977 to that in 2007?
Offer a terse response. 0.96. What is the ratio of the Female students (as % of total students) in Thailand in 1977 to that in 2007?
Ensure brevity in your answer.  0.98. What is the ratio of the Female students (as % of total students) in Australia in 1978 to that in 2004?
Offer a terse response. 1. What is the ratio of the Female students (as % of total students) of Kenya in 1978 to that in 2004?
Provide a short and direct response. 0.98. What is the ratio of the Female students (as % of total students) of Micronesia in 1978 to that in 2004?
Offer a terse response. 1. What is the ratio of the Female students (as % of total students) of Thailand in 1978 to that in 2004?
Offer a very short reply. 0.98. What is the ratio of the Female students (as % of total students) of Australia in 1978 to that in 2005?
Give a very brief answer. 1. What is the ratio of the Female students (as % of total students) in Kenya in 1978 to that in 2005?
Ensure brevity in your answer.  0.97. What is the ratio of the Female students (as % of total students) of Micronesia in 1978 to that in 2005?
Offer a terse response. 1. What is the ratio of the Female students (as % of total students) of Thailand in 1978 to that in 2005?
Your response must be concise. 0.99. What is the ratio of the Female students (as % of total students) in Kenya in 1978 to that in 2007?
Ensure brevity in your answer.  0.96. What is the ratio of the Female students (as % of total students) in Micronesia in 1978 to that in 2007?
Keep it short and to the point. 0.99. What is the ratio of the Female students (as % of total students) of Thailand in 1978 to that in 2007?
Offer a very short reply. 0.98. What is the ratio of the Female students (as % of total students) in Australia in 2004 to that in 2005?
Your answer should be very brief. 1. What is the ratio of the Female students (as % of total students) of Kenya in 2004 to that in 2005?
Provide a succinct answer. 0.99. What is the ratio of the Female students (as % of total students) of Thailand in 2004 to that in 2005?
Your answer should be very brief. 1. What is the ratio of the Female students (as % of total students) in Kenya in 2004 to that in 2007?
Your response must be concise. 0.98. What is the ratio of the Female students (as % of total students) in Micronesia in 2004 to that in 2007?
Ensure brevity in your answer.  0.99. What is the ratio of the Female students (as % of total students) in Kenya in 2005 to that in 2007?
Provide a short and direct response. 0.99. What is the ratio of the Female students (as % of total students) in Micronesia in 2005 to that in 2007?
Your answer should be compact. 0.98. What is the ratio of the Female students (as % of total students) in Thailand in 2005 to that in 2007?
Provide a short and direct response. 1. What is the difference between the highest and the second highest Female students (as % of total students) of Australia?
Ensure brevity in your answer.  0.03. What is the difference between the highest and the second highest Female students (as % of total students) of Kenya?
Keep it short and to the point. 0.64. What is the difference between the highest and the second highest Female students (as % of total students) in Micronesia?
Your answer should be compact. 0.64. What is the difference between the highest and the second highest Female students (as % of total students) of Thailand?
Keep it short and to the point. 0.03. What is the difference between the highest and the lowest Female students (as % of total students) in Australia?
Ensure brevity in your answer.  0.11. What is the difference between the highest and the lowest Female students (as % of total students) in Kenya?
Offer a terse response. 3. What is the difference between the highest and the lowest Female students (as % of total students) in Micronesia?
Your answer should be very brief. 1.73. What is the difference between the highest and the lowest Female students (as % of total students) of Thailand?
Your answer should be very brief. 1.19. 